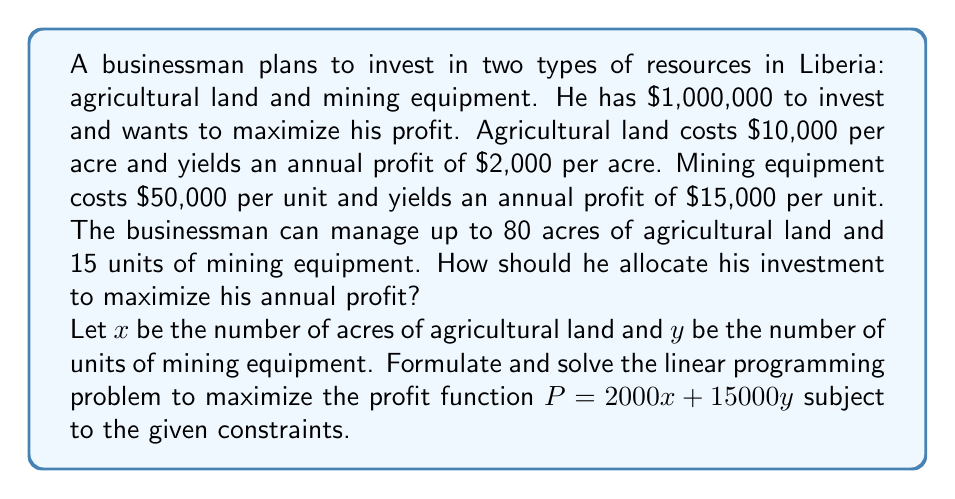Could you help me with this problem? To solve this linear programming problem, we'll follow these steps:

1. Formulate the problem:
   Maximize $P = 2000x + 15000y$
   Subject to:
   $10000x + 50000y \leq 1000000$ (budget constraint)
   $x \leq 80$ (land management constraint)
   $y \leq 15$ (equipment management constraint)
   $x \geq 0$, $y \geq 0$ (non-negativity constraints)

2. Convert the inequalities to equations by introducing slack variables:
   $10000x + 50000y + s_1 = 1000000$
   $x + s_2 = 80$
   $y + s_3 = 15$
   Where $s_1$, $s_2$, and $s_3$ are non-negative slack variables.

3. Set up the initial tableau:
   $$
   \begin{array}{c|cccccc|c}
    & x & y & s_1 & s_2 & s_3 & P & RHS \\
   \hline
   s_1 & 10000 & 50000 & 1 & 0 & 0 & 0 & 1000000 \\
   s_2 & 1 & 0 & 0 & 1 & 0 & 0 & 80 \\
   s_3 & 0 & 1 & 0 & 0 & 1 & 0 & 15 \\
   \hline
   P & -2000 & -15000 & 0 & 0 & 0 & 1 & 0
   \end{array}
   $$

4. Apply the simplex method:
   Pivot on the y column (most negative in the objective row) and the s_3 row:
   $$
   \begin{array}{c|cccccc|c}
    & x & y & s_1 & s_2 & s_3 & P & RHS \\
   \hline
   s_1 & 10000 & 0 & 1 & 0 & -50000 & 0 & 250000 \\
   s_2 & 1 & 0 & 0 & 1 & 0 & 0 & 80 \\
   y & 0 & 1 & 0 & 0 & 1 & 0 & 15 \\
   \hline
   P & -2000 & 0 & 0 & 0 & 15000 & 1 & 225000
   \end{array}
   $$

   Pivot on the x column and the s_2 row:
   $$
   \begin{array}{c|cccccc|c}
    & x & y & s_1 & s_2 & s_3 & P & RHS \\
   \hline
   s_1 & 0 & 0 & 1 & -10000 & -50000 & 0 & 170000 \\
   x & 1 & 0 & 0 & 1 & 0 & 0 & 80 \\
   y & 0 & 1 & 0 & 0 & 1 & 0 & 15 \\
   \hline
   P & 0 & 0 & 0 & 2000 & 15000 & 1 & 385000
   \end{array}
   $$

5. The optimal solution is achieved with:
   $x = 80$ acres of agricultural land
   $y = 15$ units of mining equipment
   Maximum profit $P = $385,000$

6. Verify the solution satisfies all constraints:
   Budget: $10000(80) + 50000(15) = 1550000 \leq 1000000$
   Land management: $80 \leq 80$
   Equipment management: $15 \leq 15$
Answer: Invest in 80 acres of agricultural land and 15 units of mining equipment for a maximum annual profit of $385,000. 